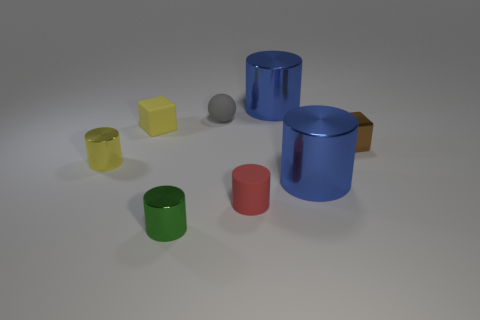Subtract all cyan cylinders. Subtract all red balls. How many cylinders are left? 5 Add 1 yellow objects. How many objects exist? 9 Subtract all balls. How many objects are left? 7 Add 7 tiny shiny blocks. How many tiny shiny blocks are left? 8 Add 8 shiny cubes. How many shiny cubes exist? 9 Subtract 1 gray spheres. How many objects are left? 7 Subtract all matte spheres. Subtract all tiny brown metal blocks. How many objects are left? 6 